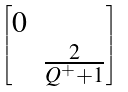Convert formula to latex. <formula><loc_0><loc_0><loc_500><loc_500>\begin{bmatrix} 0 & \\ & \frac { 2 } { Q ^ { + } + 1 } \end{bmatrix}</formula> 